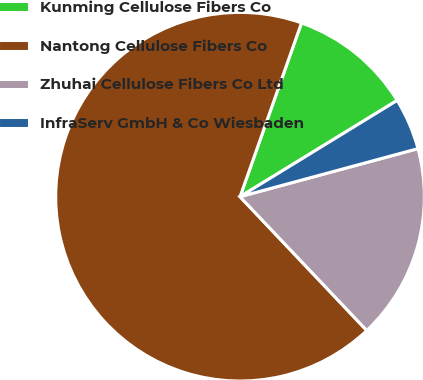<chart> <loc_0><loc_0><loc_500><loc_500><pie_chart><fcel>Kunming Cellulose Fibers Co<fcel>Nantong Cellulose Fibers Co<fcel>Zhuhai Cellulose Fibers Co Ltd<fcel>InfraServ GmbH & Co Wiesbaden<nl><fcel>10.84%<fcel>67.48%<fcel>17.13%<fcel>4.55%<nl></chart> 